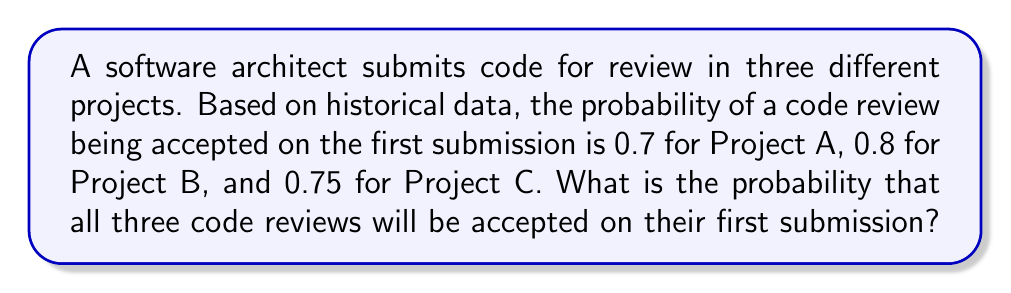Teach me how to tackle this problem. To solve this problem, we need to use the multiplication rule of probability for independent events. Since the code reviews for each project are independent of each other, we can multiply their individual probabilities to find the probability of all three being accepted on the first submission.

Let's define the events:
A: Code review accepted on first submission for Project A
B: Code review accepted on first submission for Project B
C: Code review accepted on first submission for Project C

Given probabilities:
$P(A) = 0.7$
$P(B) = 0.8$
$P(C) = 0.75$

The probability of all three code reviews being accepted on the first submission is:

$P(A \cap B \cap C) = P(A) \times P(B) \times P(C)$

Substituting the values:

$P(A \cap B \cap C) = 0.7 \times 0.8 \times 0.75$

$P(A \cap B \cap C) = 0.42$

Therefore, the probability that all three code reviews will be accepted on their first submission is 0.42 or 42%.
Answer: 0.42 